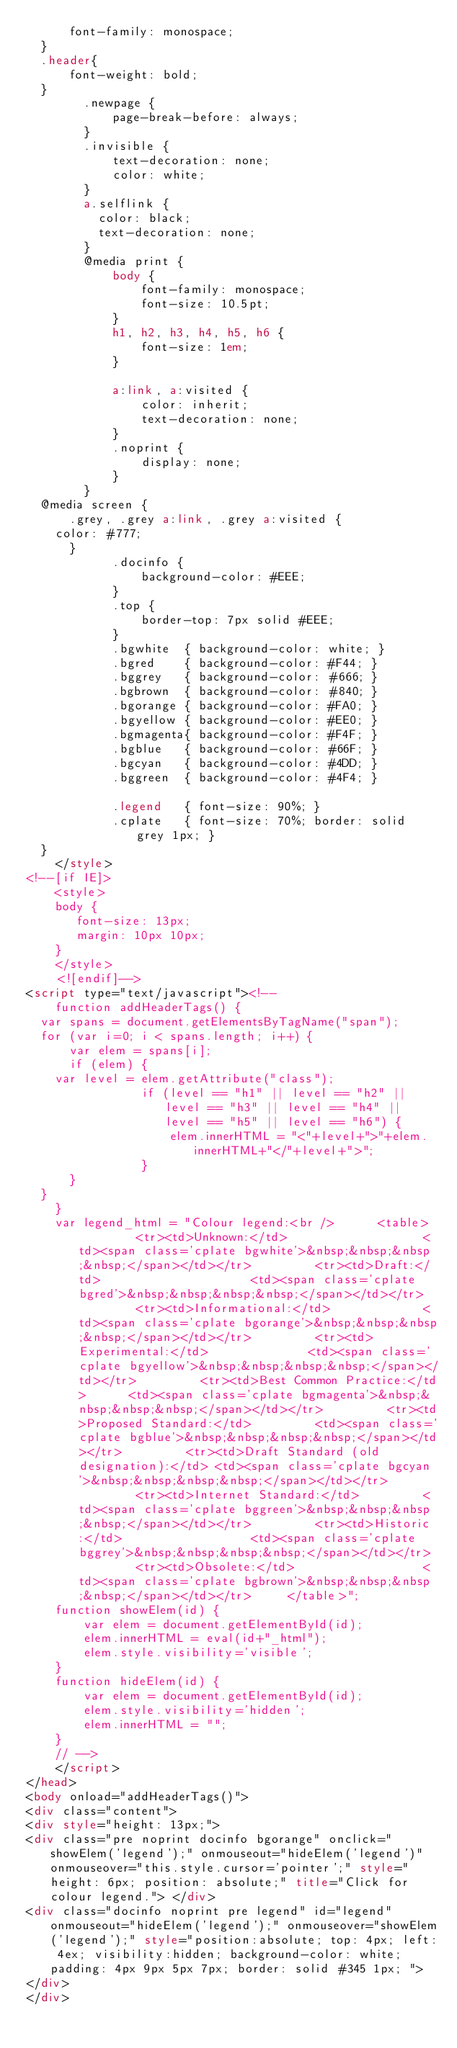Convert code to text. <code><loc_0><loc_0><loc_500><loc_500><_HTML_>	    font-family: monospace;
	}
	.header{
	    font-weight: bold;
	}
        .newpage {
            page-break-before: always;
        }
        .invisible {
            text-decoration: none;
            color: white;
        }
        a.selflink {
          color: black;
          text-decoration: none;
        }
        @media print {
            body {
                font-family: monospace;
                font-size: 10.5pt;
            }
            h1, h2, h3, h4, h5, h6 {
                font-size: 1em;
            }
        
            a:link, a:visited {
                color: inherit;
                text-decoration: none;
            }
            .noprint {
                display: none;
            }
        }
	@media screen {
	    .grey, .grey a:link, .grey a:visited {
		color: #777;
	    }
            .docinfo {
                background-color: #EEE;
            }
            .top {
                border-top: 7px solid #EEE;
            }
            .bgwhite  { background-color: white; }
            .bgred    { background-color: #F44; }
            .bggrey   { background-color: #666; }
            .bgbrown  { background-color: #840; }            
            .bgorange { background-color: #FA0; }
            .bgyellow { background-color: #EE0; }
            .bgmagenta{ background-color: #F4F; }
            .bgblue   { background-color: #66F; }
            .bgcyan   { background-color: #4DD; }
            .bggreen  { background-color: #4F4; }

            .legend   { font-size: 90%; }
            .cplate   { font-size: 70%; border: solid grey 1px; }
	}
    </style>
<!--[if IE]>
    <style>
    body {
       font-size: 13px;
       margin: 10px 10px;
    }
    </style>
    <![endif]-->
<script type="text/javascript"><!--
    function addHeaderTags() {
	var spans = document.getElementsByTagName("span");
	for (var i=0; i < spans.length; i++) {
	    var elem = spans[i];
	    if (elem) {
		var level = elem.getAttribute("class");
                if (level == "h1" || level == "h2" || level == "h3" || level == "h4" || level == "h5" || level == "h6") {
                    elem.innerHTML = "<"+level+">"+elem.innerHTML+"</"+level+">";		
                }
	    }
	}
    }
    var legend_html = "Colour legend:<br />      <table>         <tr><td>Unknown:</td>                   <td><span class='cplate bgwhite'>&nbsp;&nbsp;&nbsp;&nbsp;</span></td></tr>         <tr><td>Draft:</td>                     <td><span class='cplate bgred'>&nbsp;&nbsp;&nbsp;&nbsp;</span></td></tr>         <tr><td>Informational:</td>             <td><span class='cplate bgorange'>&nbsp;&nbsp;&nbsp;&nbsp;</span></td></tr>         <tr><td>Experimental:</td>              <td><span class='cplate bgyellow'>&nbsp;&nbsp;&nbsp;&nbsp;</span></td></tr>         <tr><td>Best Common Practice:</td>      <td><span class='cplate bgmagenta'>&nbsp;&nbsp;&nbsp;&nbsp;</span></td></tr>         <tr><td>Proposed Standard:</td>         <td><span class='cplate bgblue'>&nbsp;&nbsp;&nbsp;&nbsp;</span></td></tr>         <tr><td>Draft Standard (old designation):</td> <td><span class='cplate bgcyan'>&nbsp;&nbsp;&nbsp;&nbsp;</span></td></tr>         <tr><td>Internet Standard:</td>         <td><span class='cplate bggreen'>&nbsp;&nbsp;&nbsp;&nbsp;</span></td></tr>         <tr><td>Historic:</td>                  <td><span class='cplate bggrey'>&nbsp;&nbsp;&nbsp;&nbsp;</span></td></tr>         <tr><td>Obsolete:</td>                  <td><span class='cplate bgbrown'>&nbsp;&nbsp;&nbsp;&nbsp;</span></td></tr>     </table>";
    function showElem(id) {
        var elem = document.getElementById(id);
        elem.innerHTML = eval(id+"_html");
        elem.style.visibility='visible';
    }
    function hideElem(id) {
        var elem = document.getElementById(id);
        elem.style.visibility='hidden';        
        elem.innerHTML = "";
    }
    // -->
    </script>
</head>
<body onload="addHeaderTags()">
<div class="content">
<div style="height: 13px;">
<div class="pre noprint docinfo bgorange" onclick="showElem('legend');" onmouseout="hideElem('legend')" onmouseover="this.style.cursor='pointer';" style="height: 6px; position: absolute;" title="Click for colour legend."> </div>
<div class="docinfo noprint pre legend" id="legend" onmouseout="hideElem('legend');" onmouseover="showElem('legend');" style="position:absolute; top: 4px; left: 4ex; visibility:hidden; background-color: white; padding: 4px 9px 5px 7px; border: solid #345 1px; ">
</div>
</div></code> 